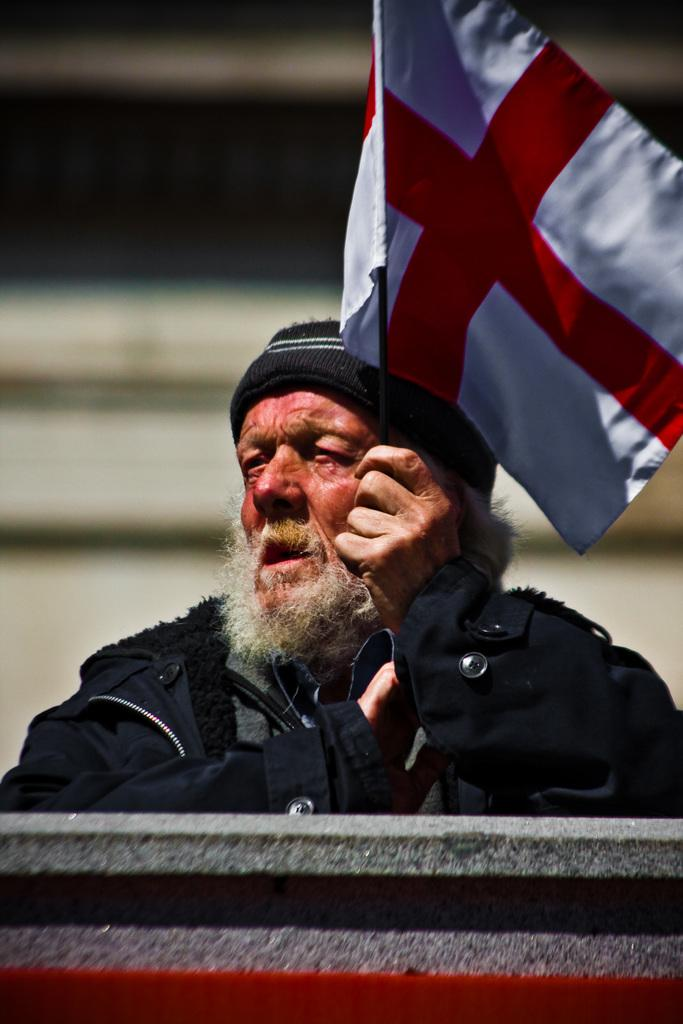What can be seen in the image? There is a person in the image. Can you describe the person's clothing? The person is wearing a black jacket. What is the person holding in the image? The person is holding a cloth. What colors are present on the cloth? The cloth is in white and red colors. What religious symbol can be seen on the person's jacket in the image? There is no religious symbol present on the person's jacket in the image. 